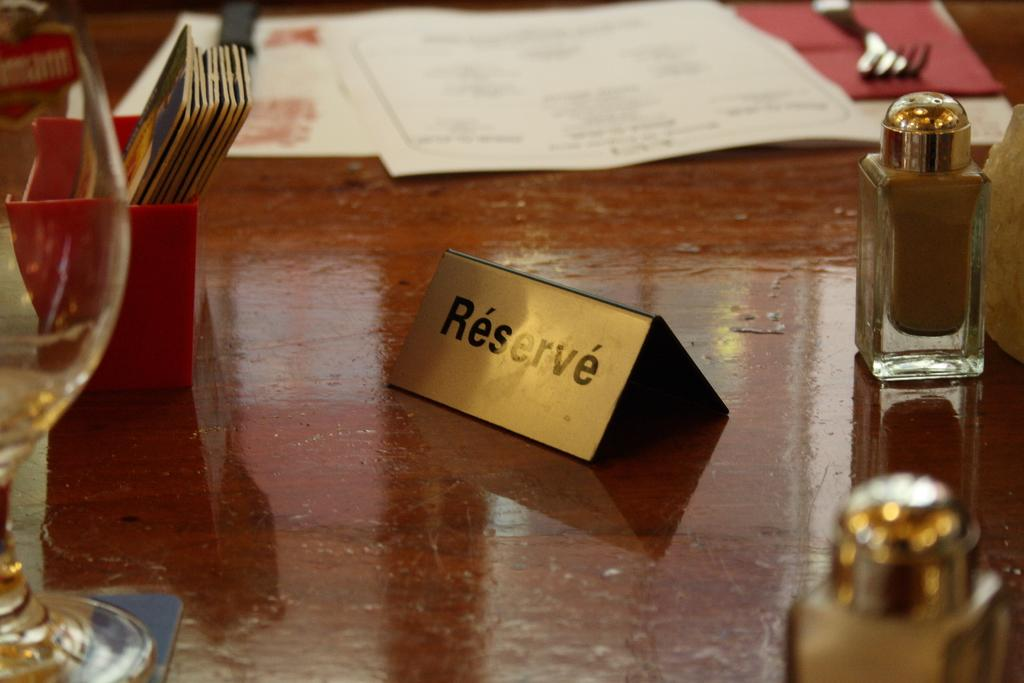<image>
Render a clear and concise summary of the photo. A restaurant dining table with a gold "reserve" sign sitting on it. 